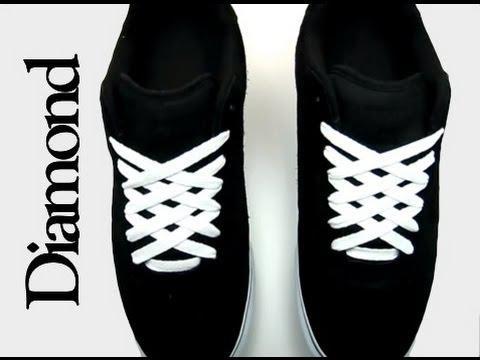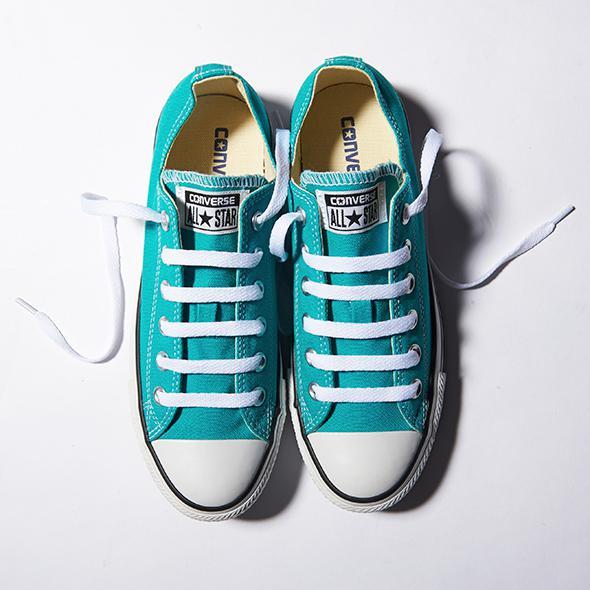The first image is the image on the left, the second image is the image on the right. Given the left and right images, does the statement "All of the shoes shown have the same color laces." hold true? Answer yes or no. Yes. The first image is the image on the left, the second image is the image on the right. Assess this claim about the two images: "There is a total of four shoes.". Correct or not? Answer yes or no. Yes. 